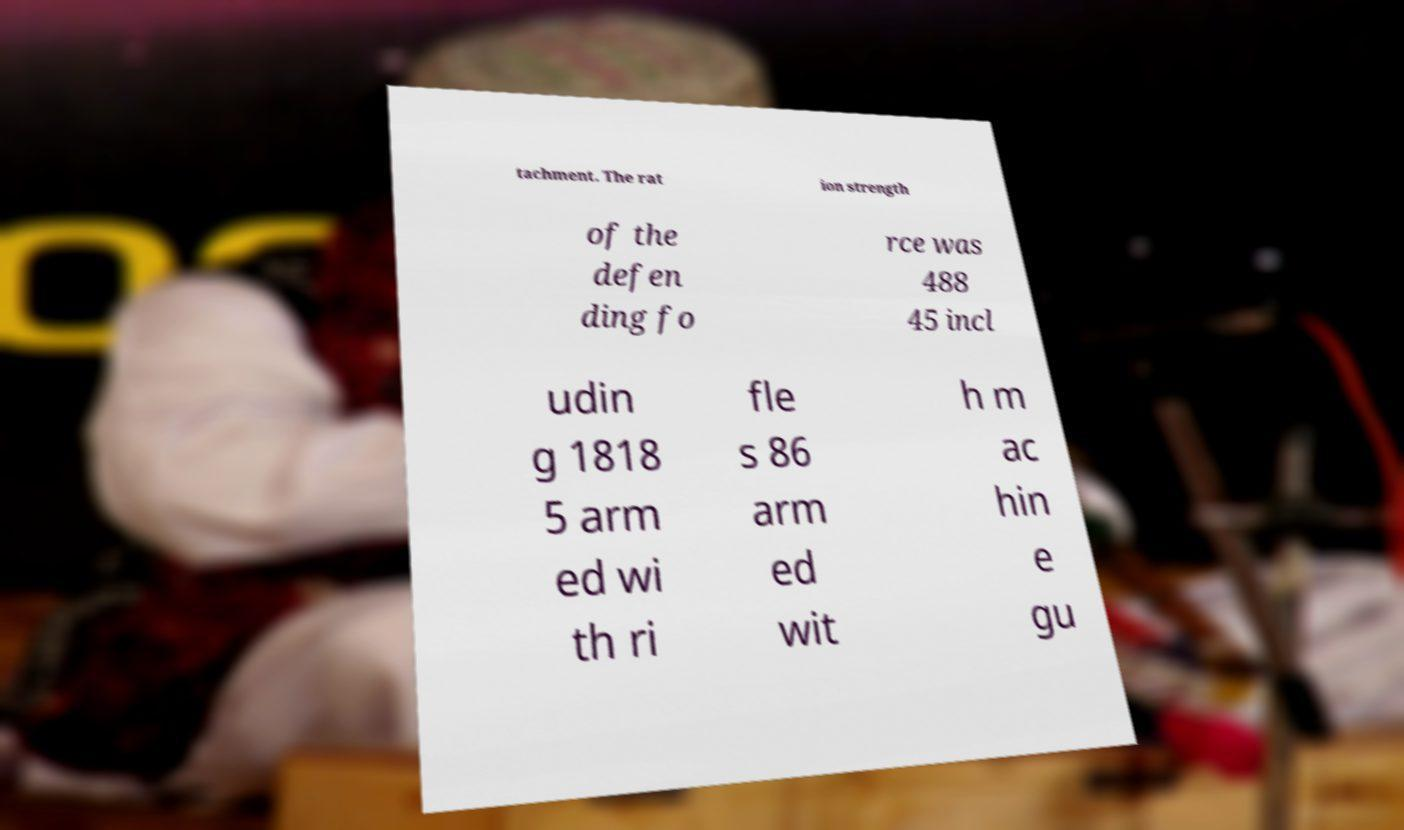There's text embedded in this image that I need extracted. Can you transcribe it verbatim? tachment. The rat ion strength of the defen ding fo rce was 488 45 incl udin g 1818 5 arm ed wi th ri fle s 86 arm ed wit h m ac hin e gu 